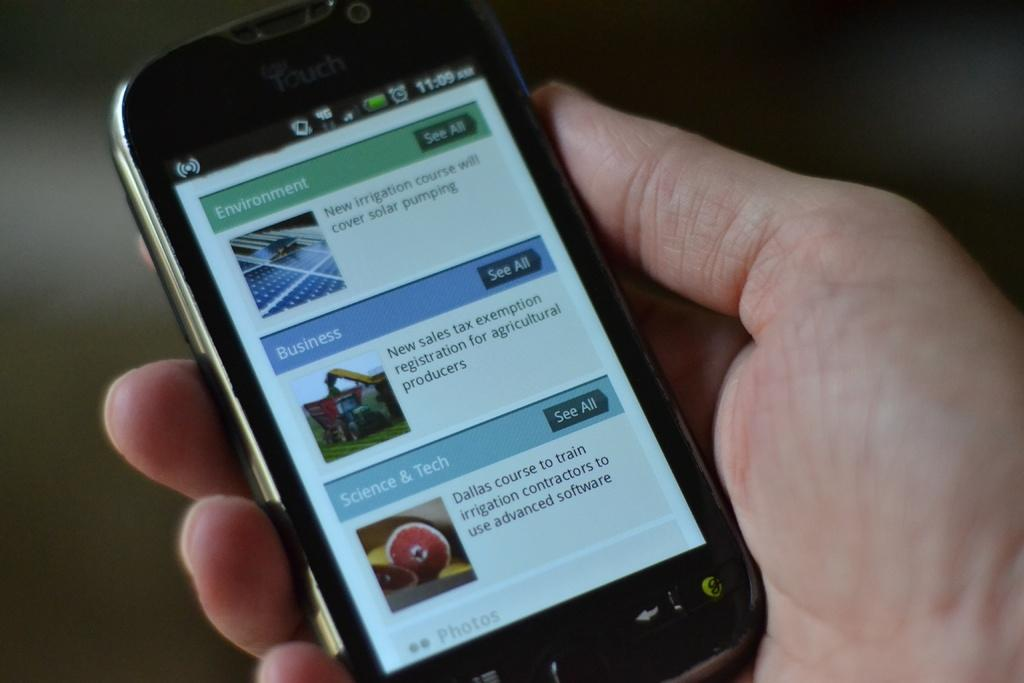<image>
Give a short and clear explanation of the subsequent image. An iTouch device open to a page about the environment, business and science and tech. 